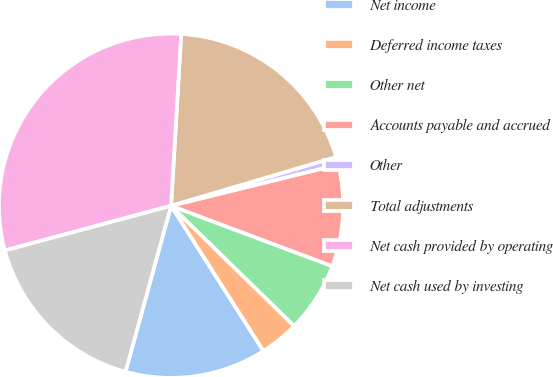<chart> <loc_0><loc_0><loc_500><loc_500><pie_chart><fcel>Net income<fcel>Deferred income taxes<fcel>Other net<fcel>Accounts payable and accrued<fcel>Other<fcel>Total adjustments<fcel>Net cash provided by operating<fcel>Net cash used by investing<nl><fcel>13.28%<fcel>3.67%<fcel>6.61%<fcel>9.55%<fcel>0.73%<fcel>19.49%<fcel>30.13%<fcel>16.55%<nl></chart> 